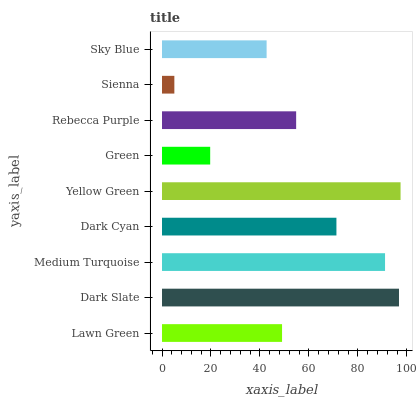Is Sienna the minimum?
Answer yes or no. Yes. Is Yellow Green the maximum?
Answer yes or no. Yes. Is Dark Slate the minimum?
Answer yes or no. No. Is Dark Slate the maximum?
Answer yes or no. No. Is Dark Slate greater than Lawn Green?
Answer yes or no. Yes. Is Lawn Green less than Dark Slate?
Answer yes or no. Yes. Is Lawn Green greater than Dark Slate?
Answer yes or no. No. Is Dark Slate less than Lawn Green?
Answer yes or no. No. Is Rebecca Purple the high median?
Answer yes or no. Yes. Is Rebecca Purple the low median?
Answer yes or no. Yes. Is Green the high median?
Answer yes or no. No. Is Green the low median?
Answer yes or no. No. 